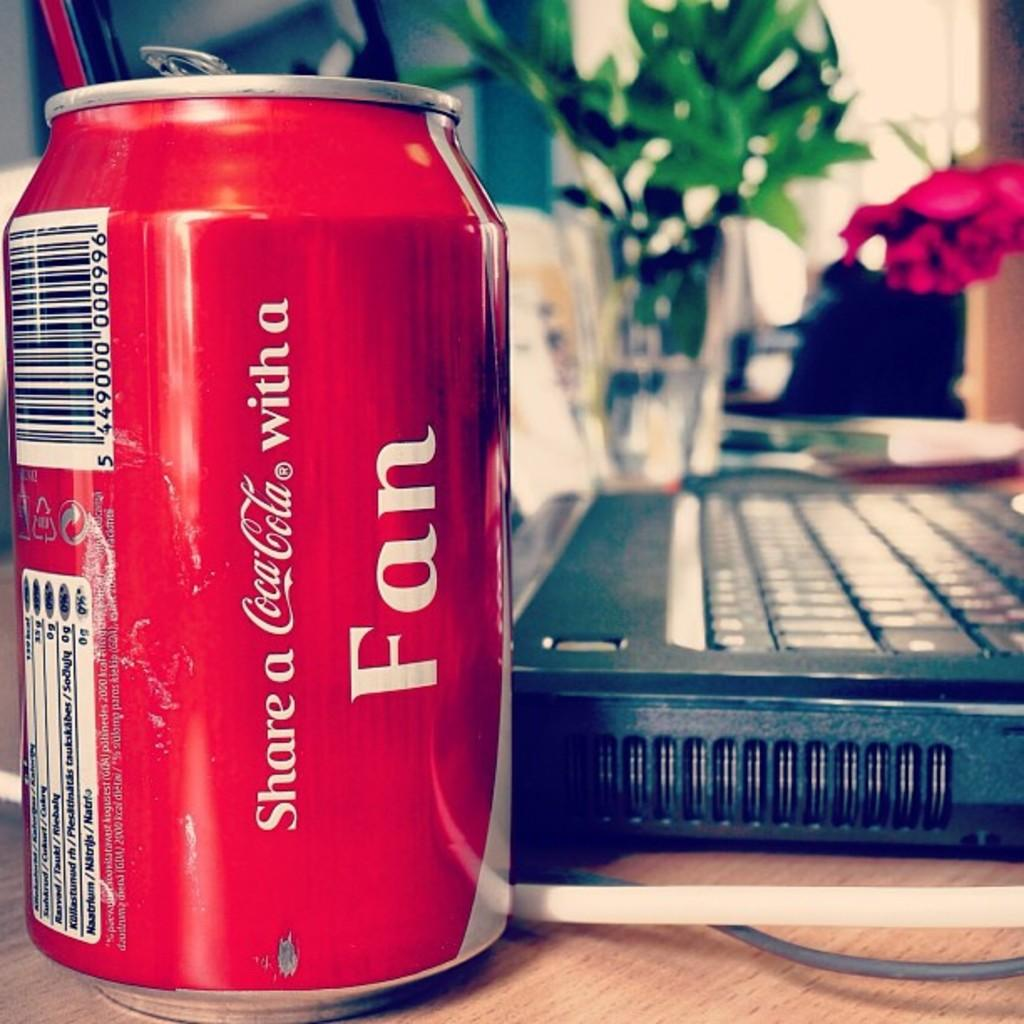What object is made of metal in the image? There is a tin in the image. What electronic device is present on a table in the image? There is a laptop on a table in the image. What type of living organism can be seen in the image? There is a plant and a flower in the image. How would you describe the background of the image? The background of the image is blurry. What type of fruit is hanging from the plant in the image? There is no fruit visible on the plant in the image. What knowledge can be gained from the image about the sense of smell? The image does not provide any information about the sense of smell or any other sense. 